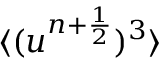<formula> <loc_0><loc_0><loc_500><loc_500>\langle ( u ^ { n + \frac { 1 } { 2 } } ) ^ { 3 } \rangle</formula> 